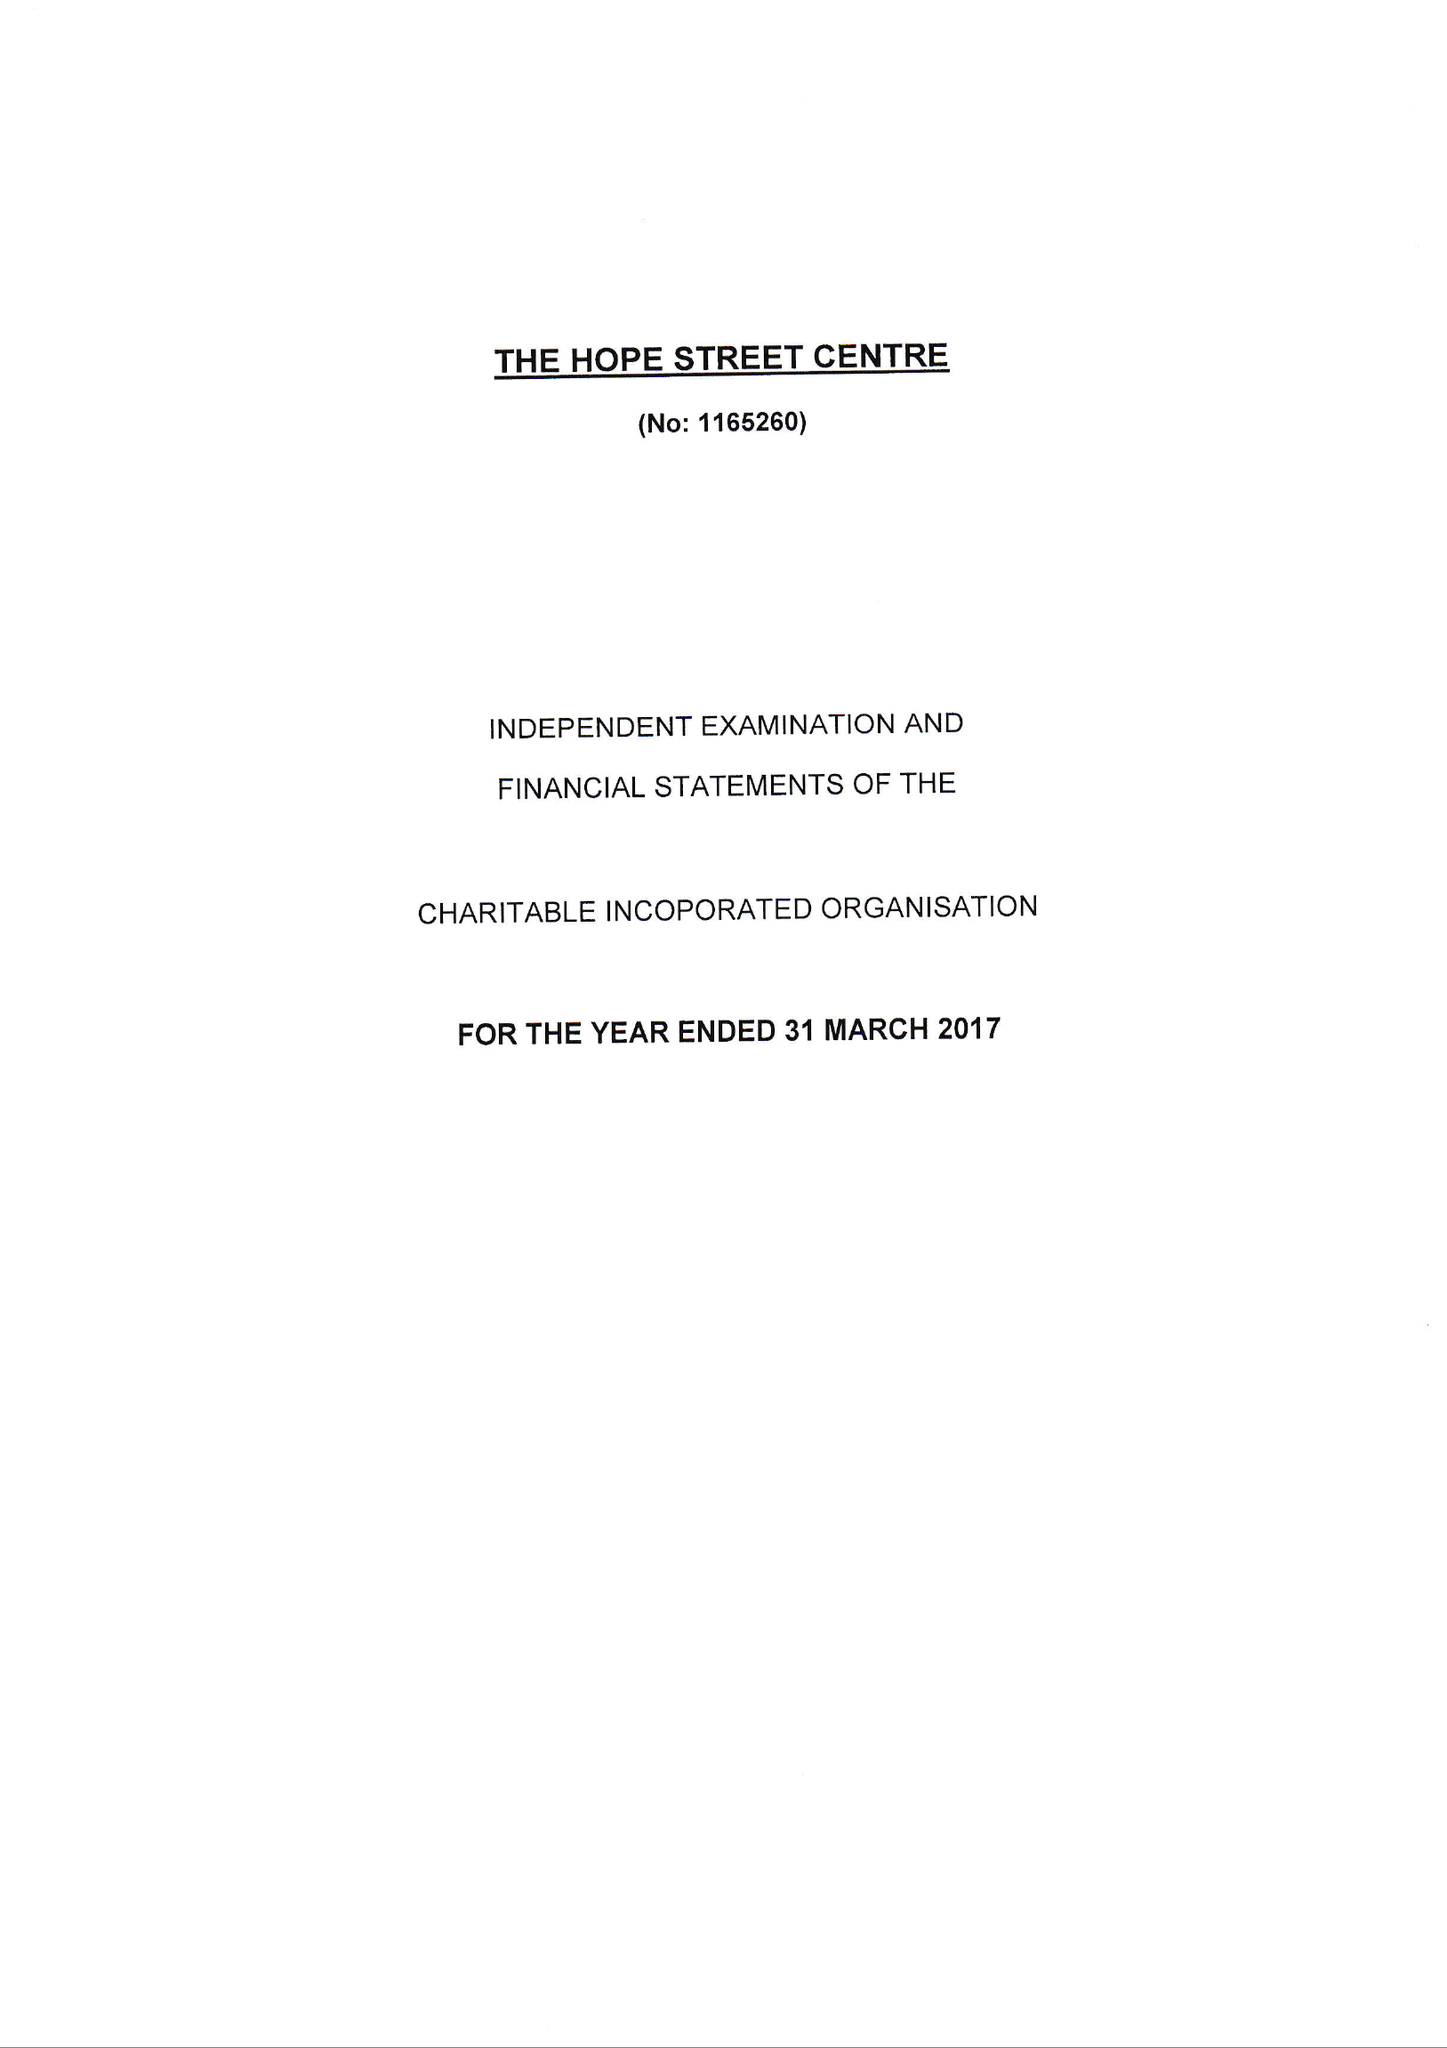What is the value for the charity_name?
Answer the question using a single word or phrase. The Hope Street Centre 